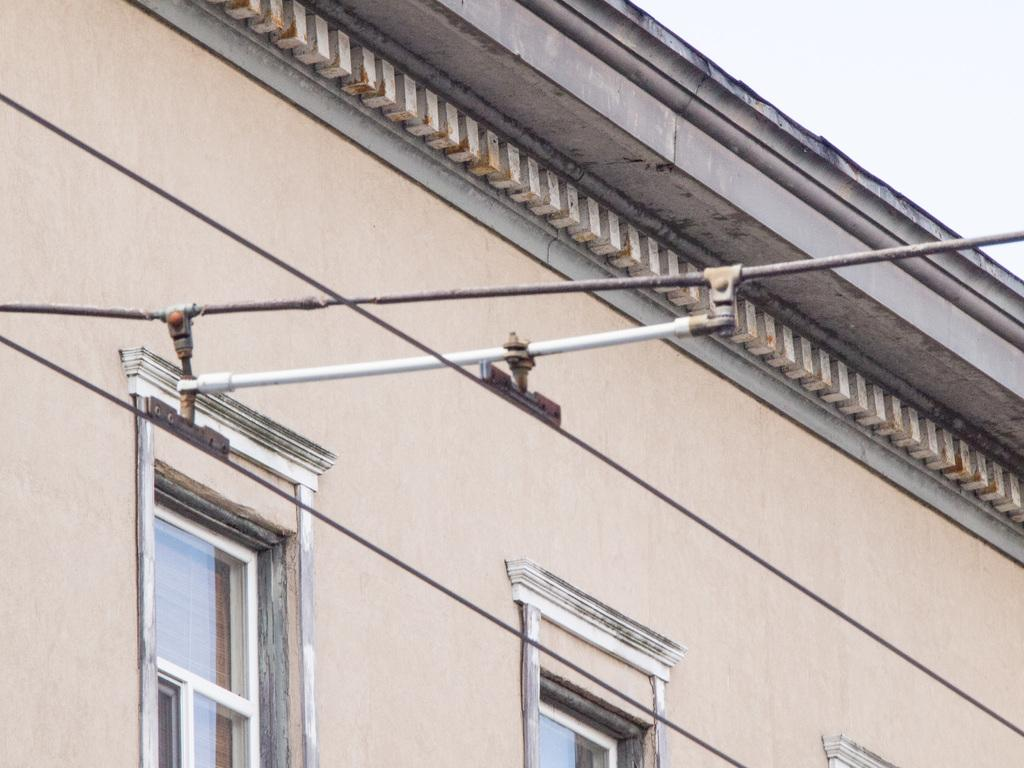What is attached to the wires in the image? There is a metal rod attached to the wires in the image. What can be seen in the background of the image? There is a wall with windows in the background of the image. What part of the sky is visible in the image? The sky is visible at the top right of the image. Can you see a snake biting the metal rod in the image? No, there is no snake or any indication of a bite in the image. 